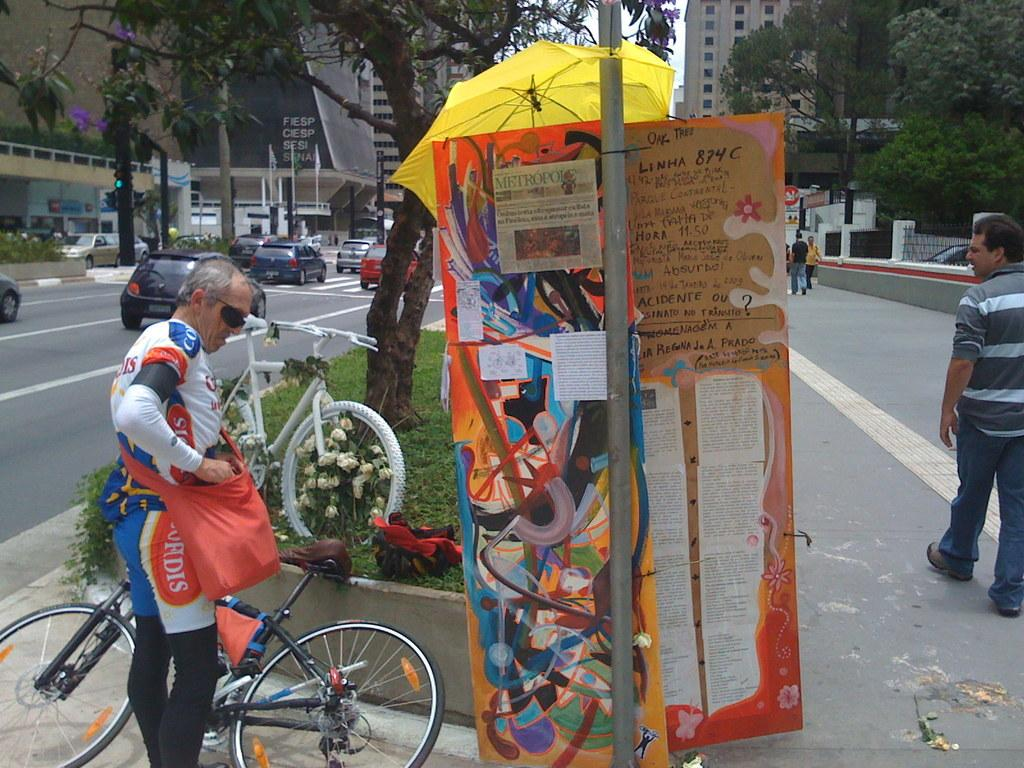What are the people in the image doing? There is a group of people walking on the road in the image. What else can be seen on the road besides the people? There are vehicles on the road in the image. What structures are visible in the background? There are buildings visible in the image. What type of natural elements can be seen in the image? There are trees in the image. What type of pump is being used by the nation in the image? There is no mention of a pump or a nation in the image; it features a group of people walking on the road, vehicles, buildings, and trees. 